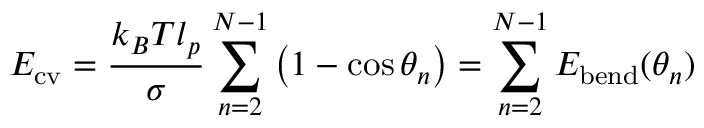Convert formula to latex. <formula><loc_0><loc_0><loc_500><loc_500>E _ { c v } = \frac { k _ { B } T l _ { p } } { \sigma } \sum _ { n = 2 } ^ { N - 1 } \left ( 1 - \cos { \theta _ { n } } \right ) = \sum _ { n = 2 } ^ { N - 1 } E _ { b e n d } ( \theta _ { n } )</formula> 